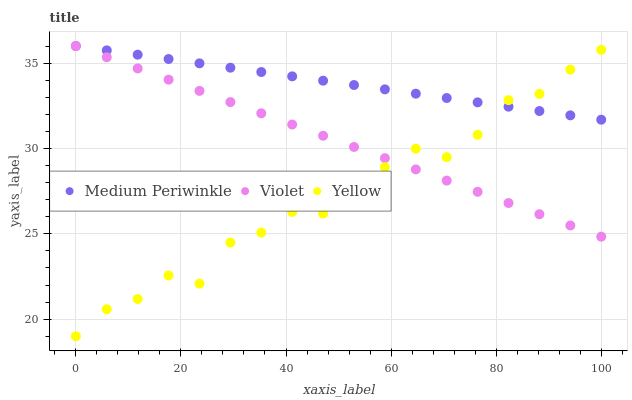Does Yellow have the minimum area under the curve?
Answer yes or no. Yes. Does Medium Periwinkle have the maximum area under the curve?
Answer yes or no. Yes. Does Violet have the minimum area under the curve?
Answer yes or no. No. Does Violet have the maximum area under the curve?
Answer yes or no. No. Is Violet the smoothest?
Answer yes or no. Yes. Is Yellow the roughest?
Answer yes or no. Yes. Is Yellow the smoothest?
Answer yes or no. No. Is Violet the roughest?
Answer yes or no. No. Does Yellow have the lowest value?
Answer yes or no. Yes. Does Violet have the lowest value?
Answer yes or no. No. Does Violet have the highest value?
Answer yes or no. Yes. Does Yellow have the highest value?
Answer yes or no. No. Does Violet intersect Yellow?
Answer yes or no. Yes. Is Violet less than Yellow?
Answer yes or no. No. Is Violet greater than Yellow?
Answer yes or no. No. 